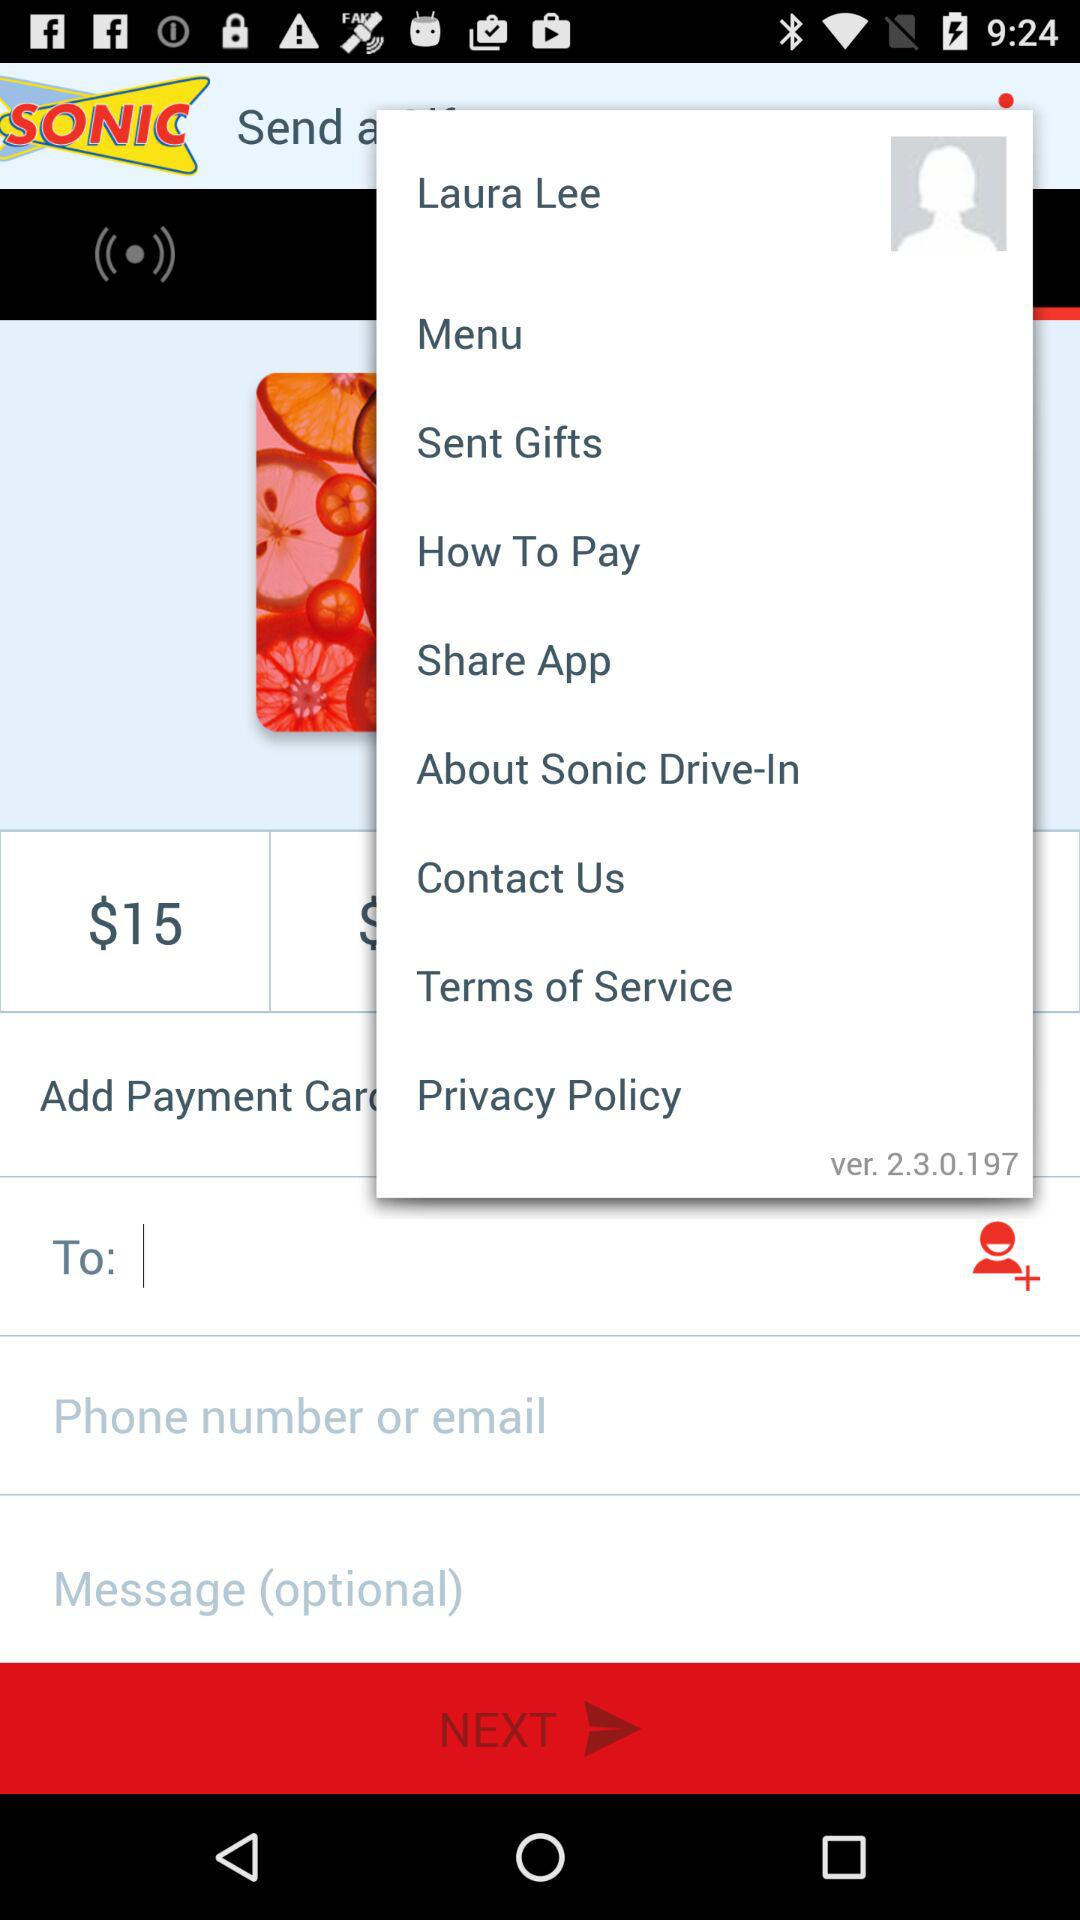What is the profile name? The profile name is Laura Lee. 